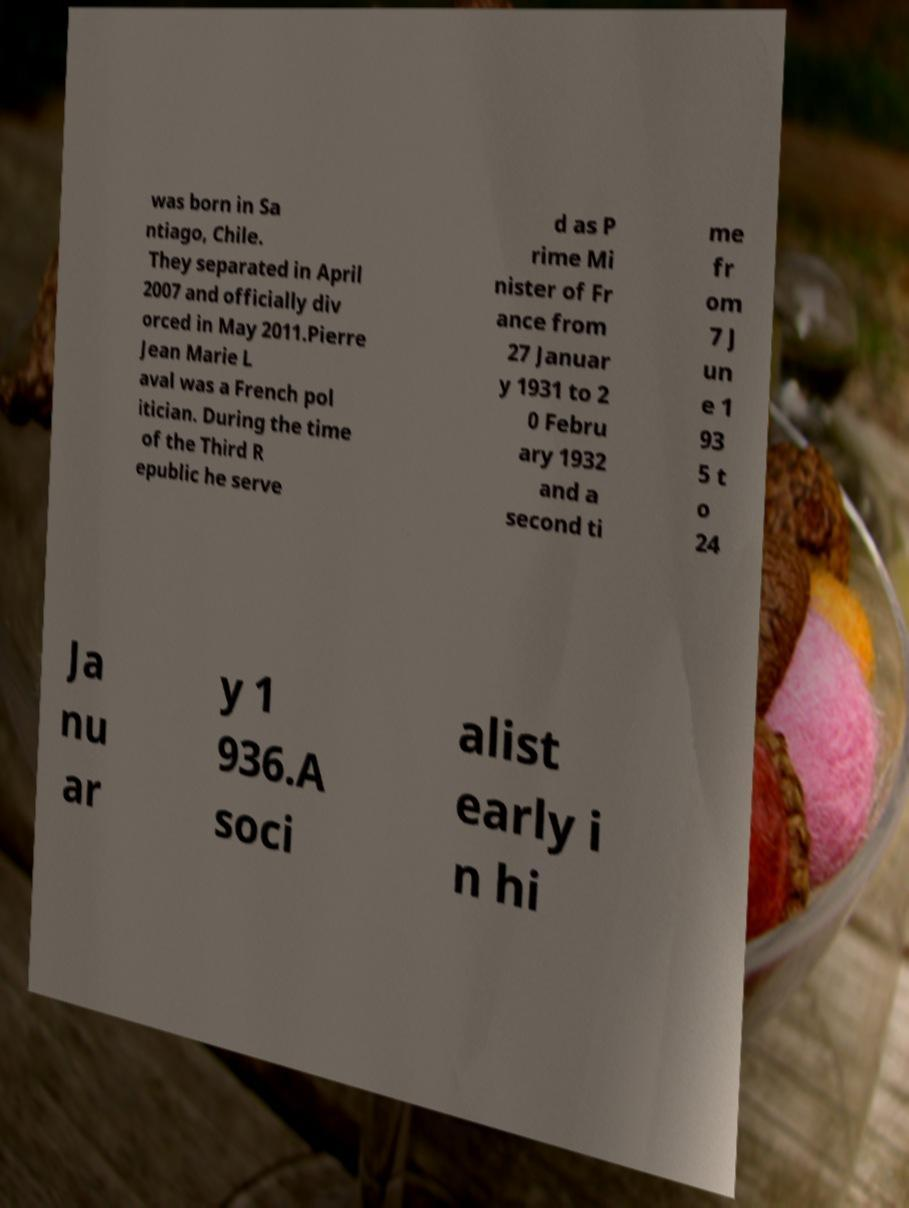Could you extract and type out the text from this image? was born in Sa ntiago, Chile. They separated in April 2007 and officially div orced in May 2011.Pierre Jean Marie L aval was a French pol itician. During the time of the Third R epublic he serve d as P rime Mi nister of Fr ance from 27 Januar y 1931 to 2 0 Febru ary 1932 and a second ti me fr om 7 J un e 1 93 5 t o 24 Ja nu ar y 1 936.A soci alist early i n hi 